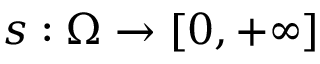<formula> <loc_0><loc_0><loc_500><loc_500>s \colon \Omega \to [ 0 , + \infty ]</formula> 